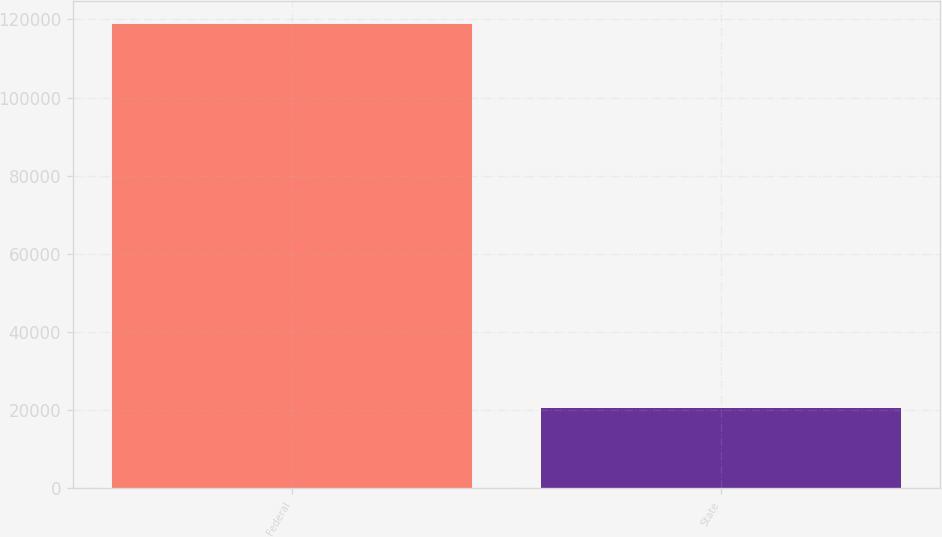<chart> <loc_0><loc_0><loc_500><loc_500><bar_chart><fcel>Federal<fcel>State<nl><fcel>118764<fcel>20595<nl></chart> 